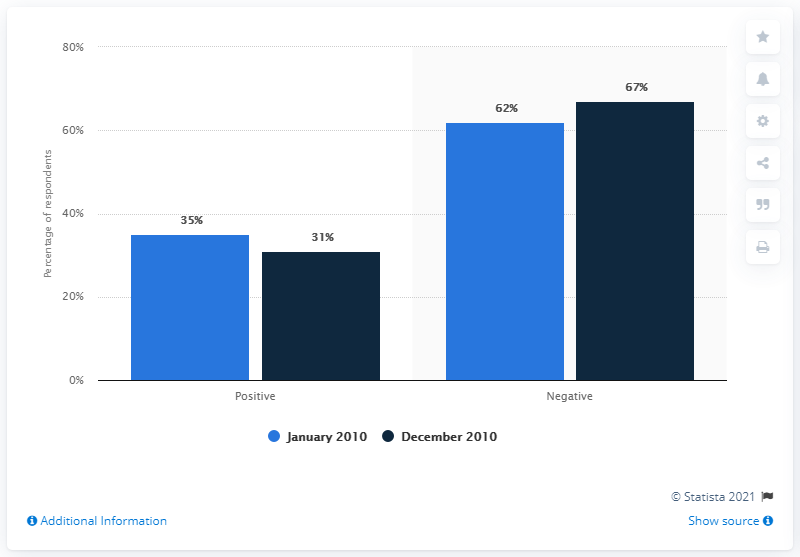Mention a couple of crucial points in this snapshot. In December 2010, the ratio between positive and negative opinions was approximately 0.46. In December 2010, the data was positive, and it was the last month of the year. 